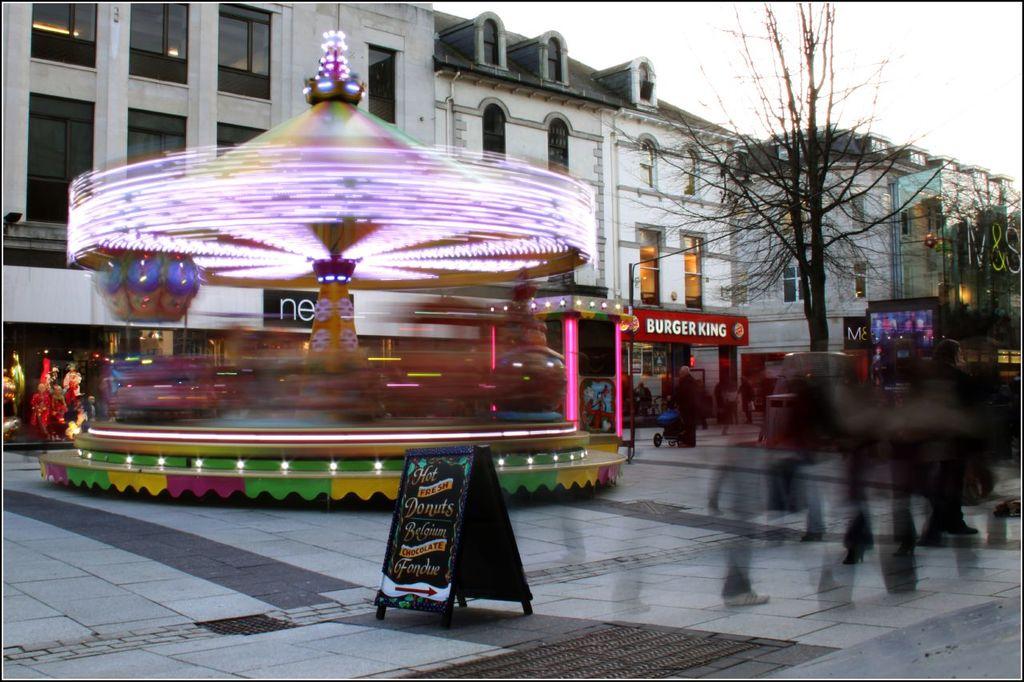What fast food restaurant can you eat at?
Ensure brevity in your answer.  Burger king. What does the sign say is fresh?
Give a very brief answer. Donuts. 